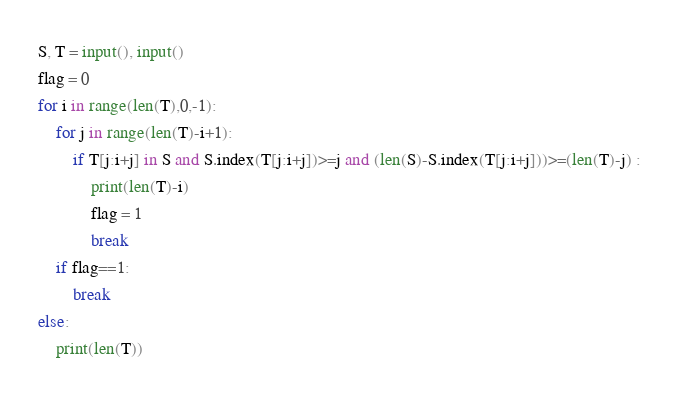<code> <loc_0><loc_0><loc_500><loc_500><_Python_>S, T = input(), input()
flag = 0
for i in range(len(T),0,-1):
    for j in range(len(T)-i+1):
        if T[j:i+j] in S and S.index(T[j:i+j])>=j and (len(S)-S.index(T[j:i+j]))>=(len(T)-j) :
            print(len(T)-i)
            flag = 1
            break
    if flag==1:
        break
else:
    print(len(T))</code> 